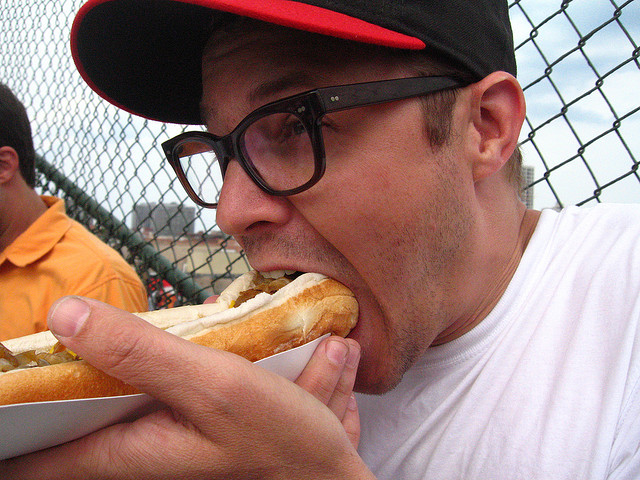<image>What is the size of this hot dog? I am not sure about the size of the hot dog. It can be either 'large' or 'foot long'. What is the size of this hot dog? I don't know the size of this hot dog. It can be either 6 inches, large, or footlong. 